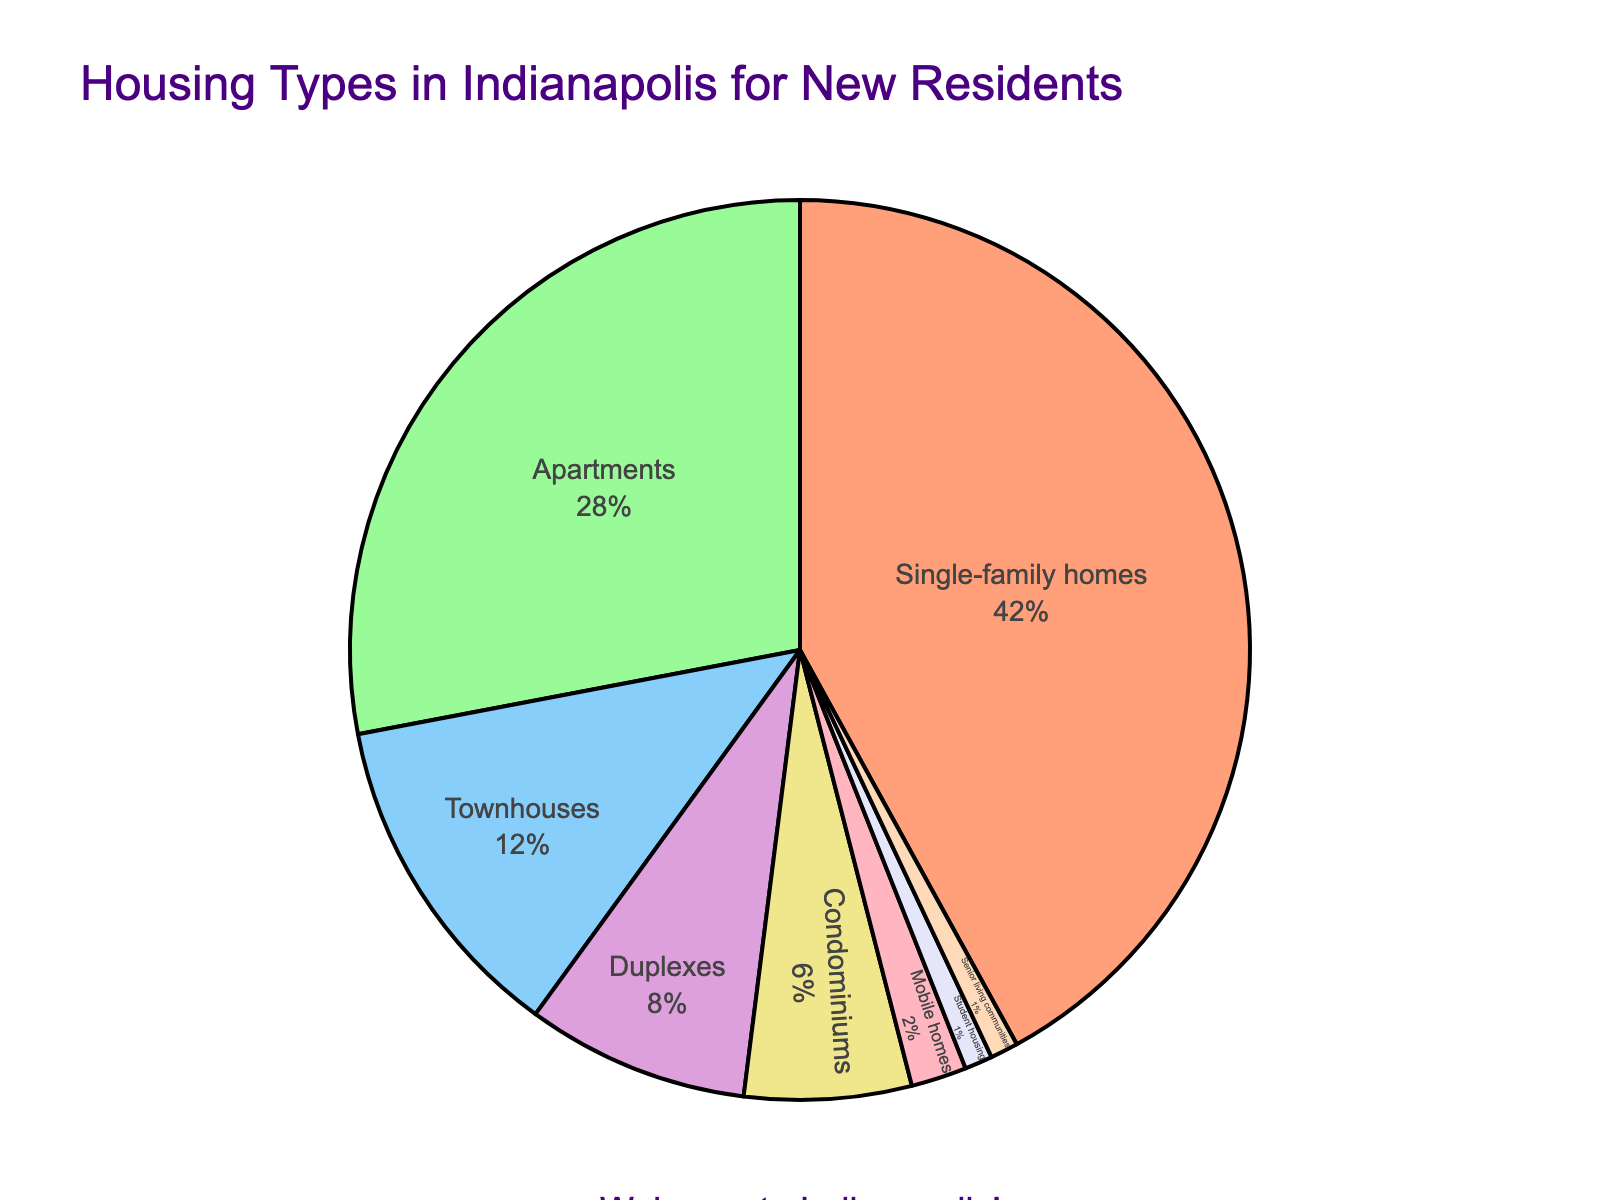What's the most common type of housing available for new residents in Indianapolis? The pie chart shows that single-family homes have the largest segment.
Answer: Single-family homes What is the proportion of townhouses and duplexes combined? Townhouses are 12% and duplexes are 8%. Adding them together gives 12% + 8% = 20%.
Answer: 20% How much more common are single-family homes than apartments? Single-family homes make up 42%, and apartments make up 28%. The difference is 42% - 28% = 14%.
Answer: 14% Which types of housing have a percentage of 1% each? The pie chart shows that student housing and senior living communities both have segments labeled as 1%.
Answer: Student housing and senior living communities What is the least common type of housing available? The smallest segment on the pie chart is labeled as 1%, applied to student housing and senior living communities.
Answer: Student housing and senior living communities Which type of housing is represented by the light yellow color in the pie chart? The light yellow segment in the chart represents condominiums.
Answer: Condominiums Is the proportion of duplexes greater than the proportion of mobile homes? Duplexes are 8%, and mobile homes are 2%. 8% is greater than 2%.
Answer: Yes Out of the available housing types, which three have the smallest proportions? The smallest segments are student housing and senior living communities (each at 1%) and mobile homes (2%).
Answer: Student housing, senior living communities, mobile homes If townhouses and condominiums were combined into a single category, what would be the new percentage? Townhouses are 12%, condominiums are 6%. Adding them together gives 12% + 6% = 18%.
Answer: 18% What proportion of the housing types listed are smaller than duplexes? Student housing (1%), senior living communities (1%), mobile homes (2%), and condominiums (6%) are all less than duplexes (8%). Adding them up gives 1% + 1% + 2% + 6% = 10%.
Answer: 10% 